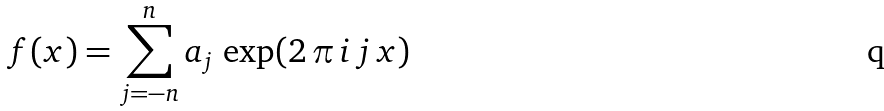<formula> <loc_0><loc_0><loc_500><loc_500>f ( x ) = \sum _ { j = - n } ^ { n } a _ { j } \, \exp ( 2 \, \pi \, i \, j \, x )</formula> 